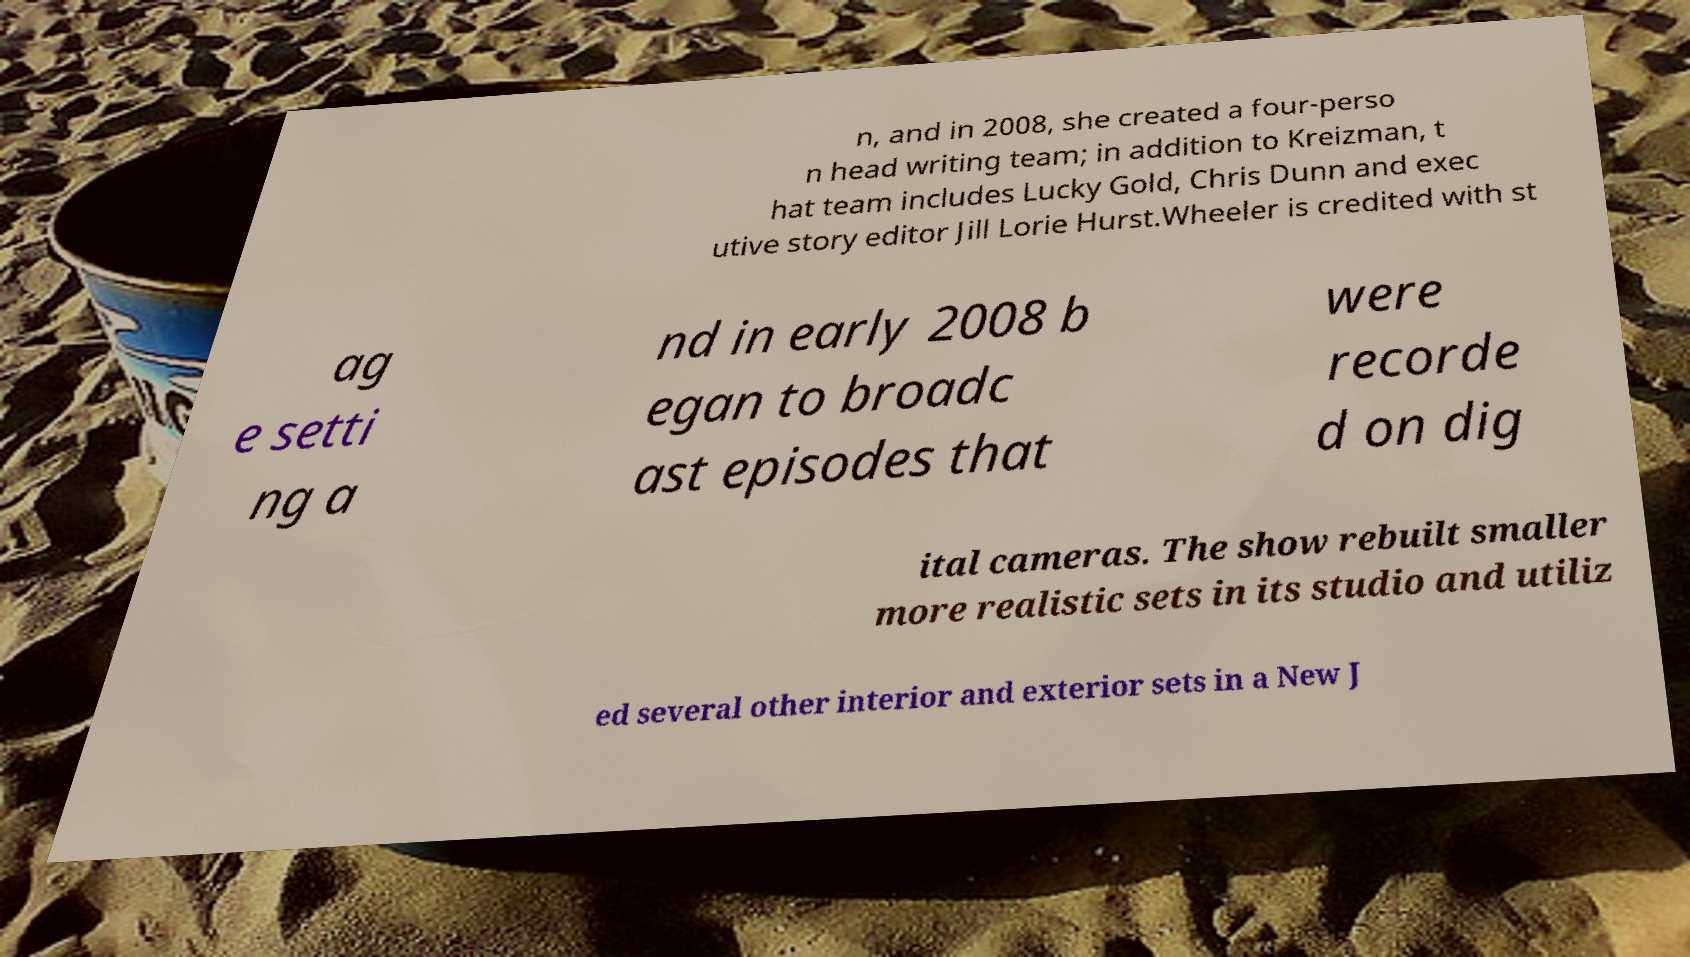Can you read and provide the text displayed in the image?This photo seems to have some interesting text. Can you extract and type it out for me? n, and in 2008, she created a four-perso n head writing team; in addition to Kreizman, t hat team includes Lucky Gold, Chris Dunn and exec utive story editor Jill Lorie Hurst.Wheeler is credited with st ag e setti ng a nd in early 2008 b egan to broadc ast episodes that were recorde d on dig ital cameras. The show rebuilt smaller more realistic sets in its studio and utiliz ed several other interior and exterior sets in a New J 